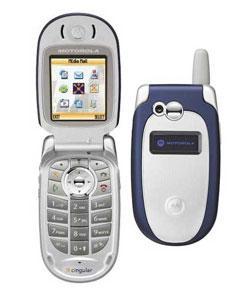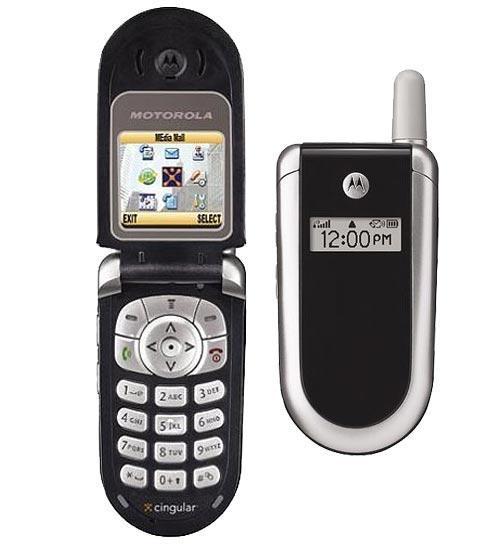The first image is the image on the left, the second image is the image on the right. Considering the images on both sides, is "Each image shows one flip phone in side-by-side open and closed views." valid? Answer yes or no. Yes. The first image is the image on the left, the second image is the image on the right. Evaluate the accuracy of this statement regarding the images: "In at least one image there are two phones, one that is open and sliver and the other is closed and blue.". Is it true? Answer yes or no. Yes. 